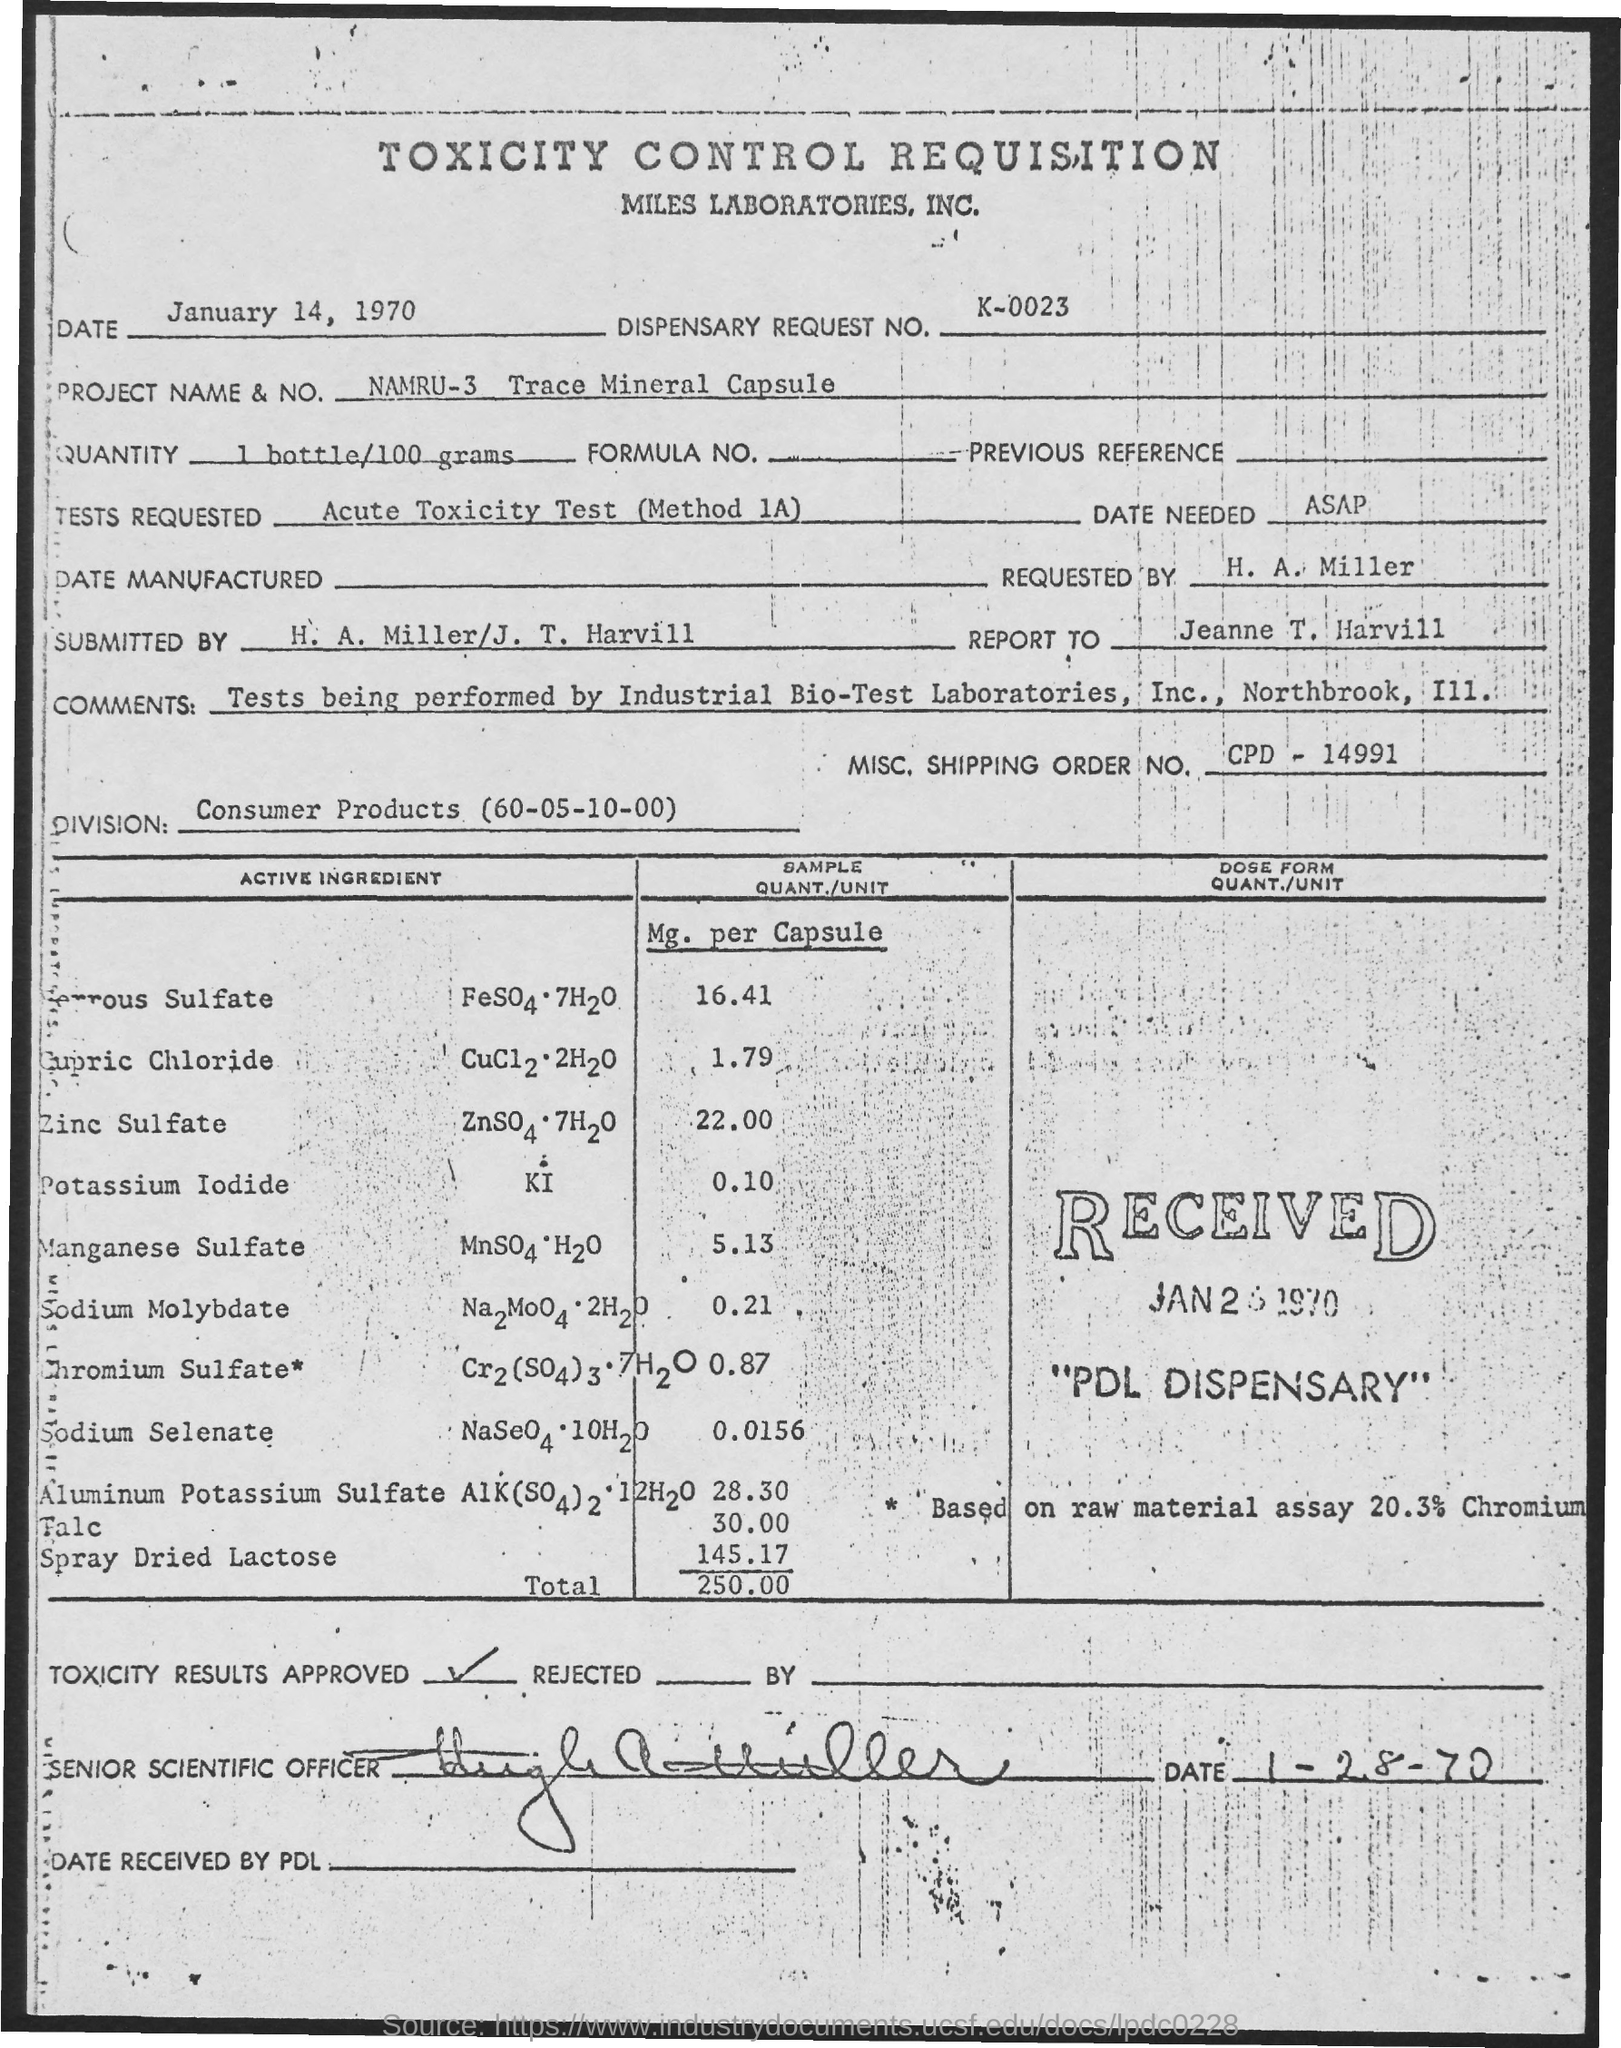Specify some key components in this picture. The division name is Consumer Products (60-05-10-00). What is the Misc.Shipping Order No.? is a code number that was generated on December 9th, 1999. The title of the document is 'Toxicity Control Requisition.' The request number for the dispensary is k-0023. The project name is "namru-3 trace mineral capsule". 